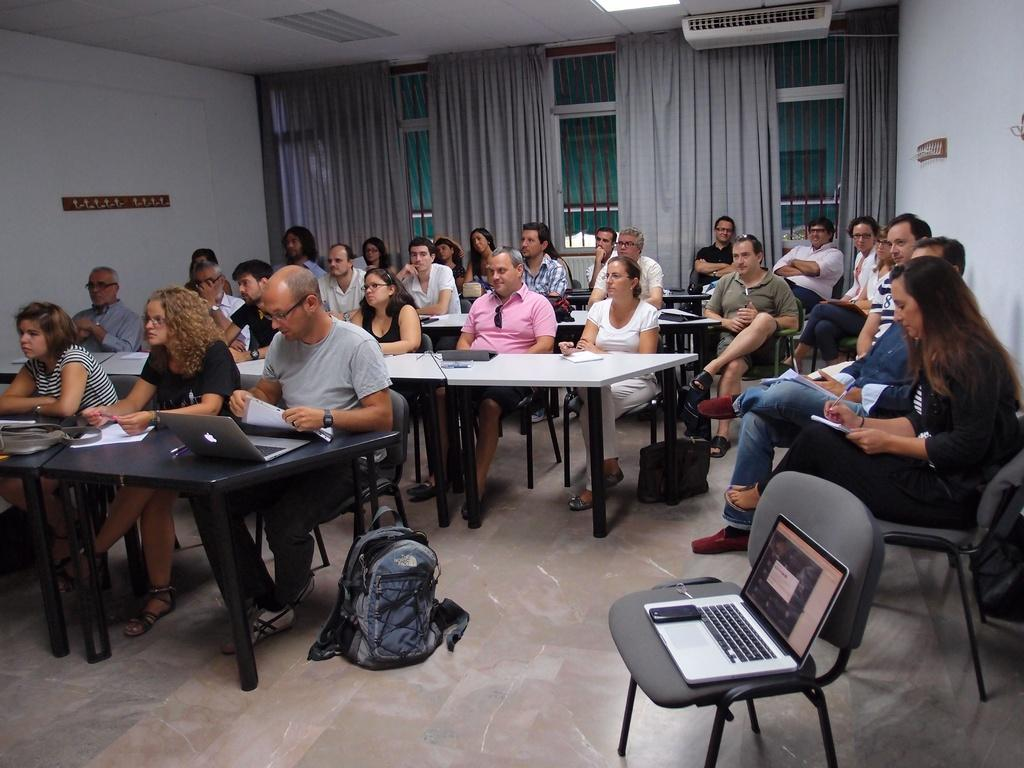What are the people in the image doing? The people in the image are sitting in chairs and operating laptops. What is on the table in front of the people? The information provided does not specify what is on the table. What is the status of the chair next to the people? There is an empty chair with a laptop on it. What is the bag resting against in the image? The bag is resting against a pole. How does the bag feel about the pole it is resting against? The bag does not have feelings, as it is an inanimate object. What type of lock is securing the laptop on the table? There is no lock mentioned or visible in the image. 